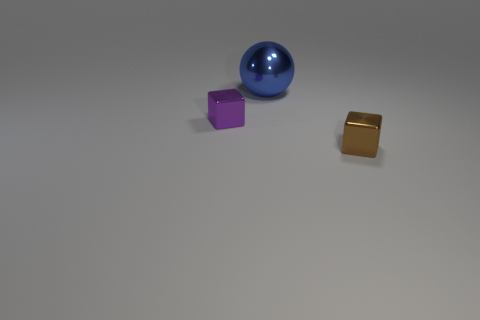Add 1 cyan blocks. How many objects exist? 4 Subtract all blocks. How many objects are left? 1 Add 2 metal things. How many metal things are left? 5 Add 1 matte blocks. How many matte blocks exist? 1 Subtract 0 gray cubes. How many objects are left? 3 Subtract all purple objects. Subtract all small blue cubes. How many objects are left? 2 